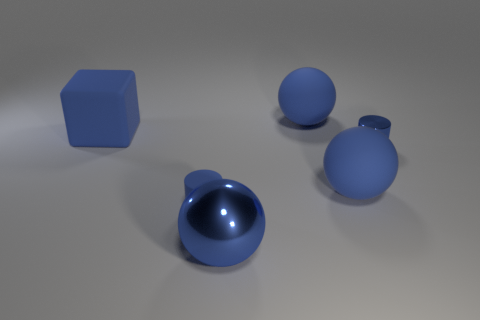There is a metal object that is the same shape as the small blue rubber thing; what is its color?
Provide a succinct answer. Blue. Does the blue cylinder in front of the tiny blue metal cylinder have the same material as the large blue object behind the blue rubber block?
Make the answer very short. Yes. There is a small metallic cylinder; is it the same color as the matte ball that is behind the blue block?
Offer a terse response. Yes. There is a rubber thing that is both to the left of the big blue metal object and behind the tiny matte cylinder; what shape is it?
Ensure brevity in your answer.  Cube. What number of yellow matte cylinders are there?
Your response must be concise. 0. What shape is the small rubber thing that is the same color as the small metallic object?
Provide a succinct answer. Cylinder. What size is the other blue object that is the same shape as the small matte thing?
Offer a very short reply. Small. There is a blue shiny thing that is in front of the small blue metal object; is it the same shape as the tiny shiny object?
Your response must be concise. No. The small object behind the small blue matte cylinder is what color?
Your answer should be compact. Blue. What number of other things are there of the same size as the blue rubber block?
Your response must be concise. 3. 